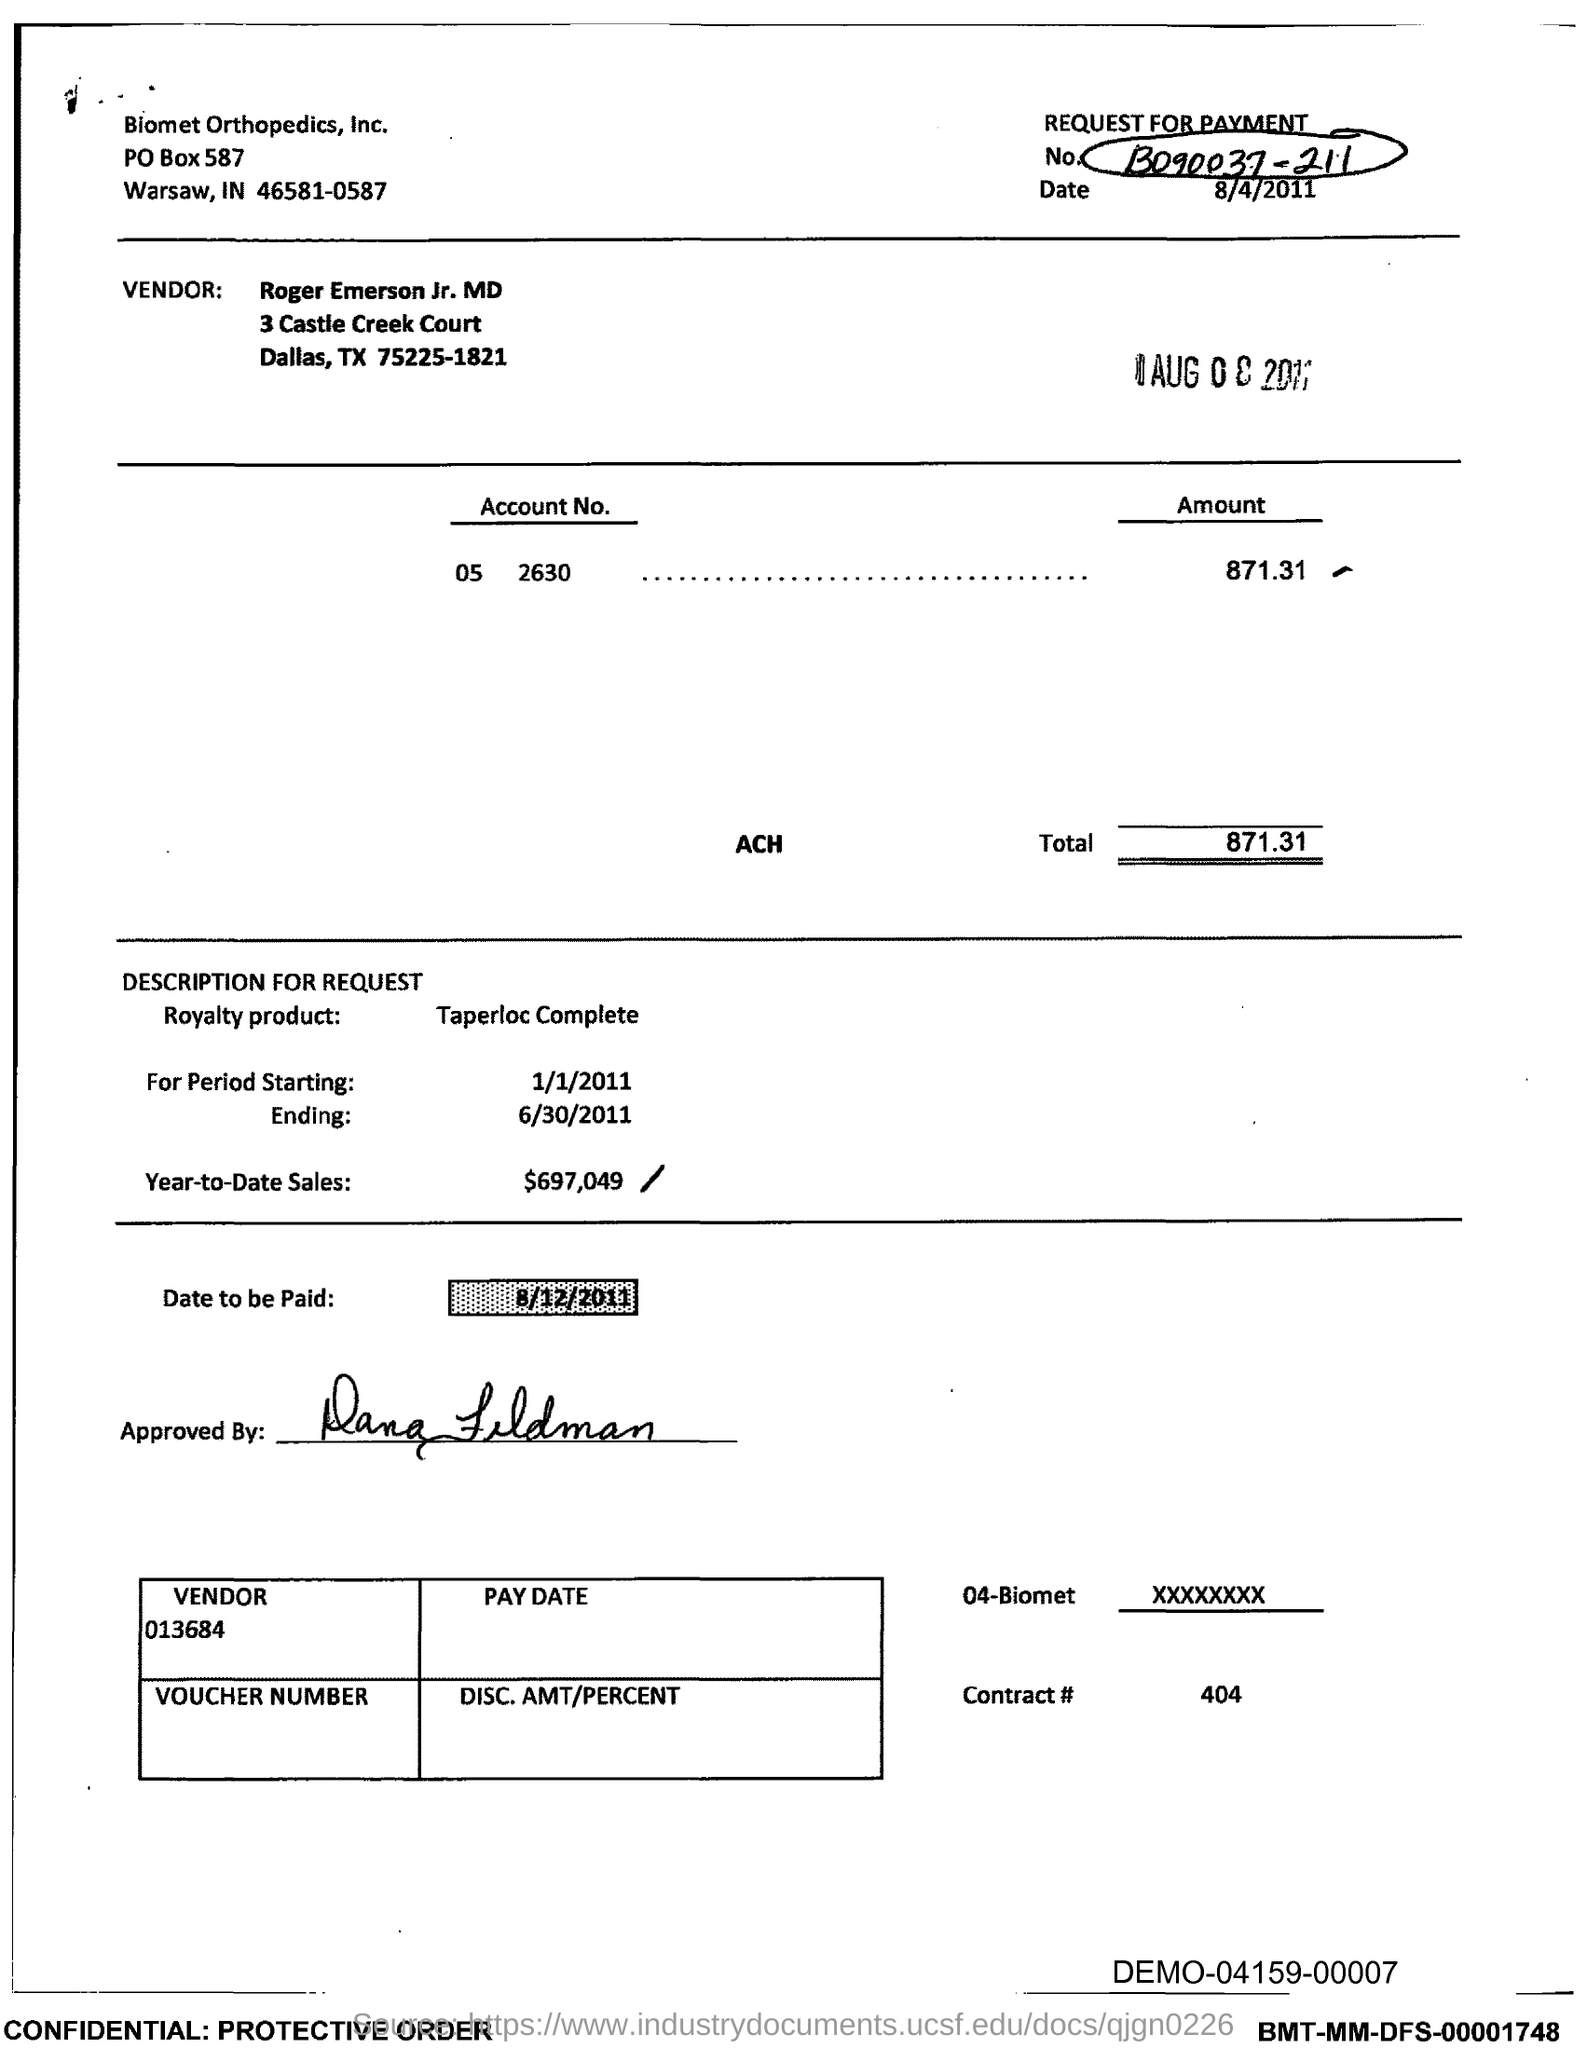What is the Contract # Number?
Offer a very short reply. 404. What is the date to be paid?
Offer a terse response. 8/12/2011. What is the Year-to-Date-Sales?
Provide a short and direct response. $697,049. 